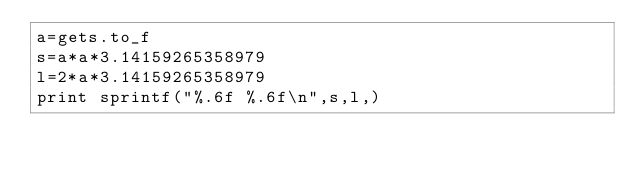<code> <loc_0><loc_0><loc_500><loc_500><_Ruby_>a=gets.to_f
s=a*a*3.14159265358979
l=2*a*3.14159265358979
print sprintf("%.6f %.6f\n",s,l,)</code> 